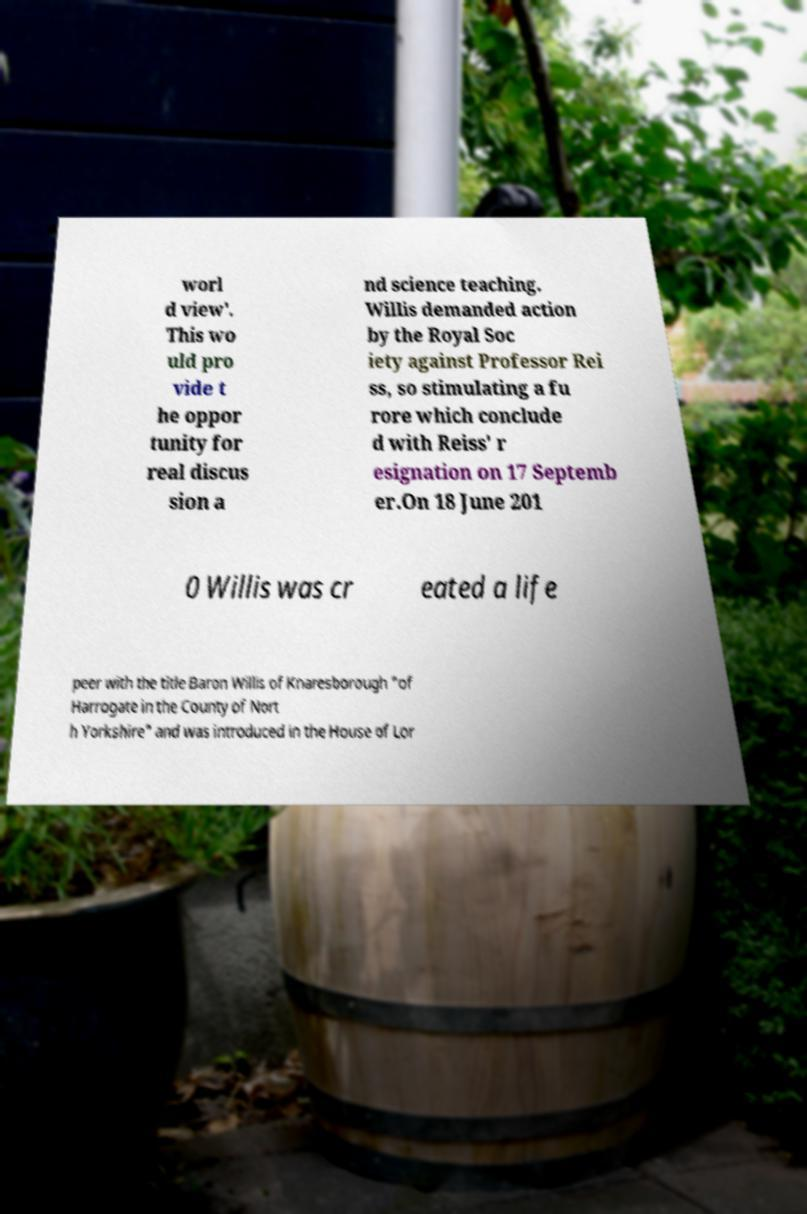I need the written content from this picture converted into text. Can you do that? worl d view'. This wo uld pro vide t he oppor tunity for real discus sion a nd science teaching. Willis demanded action by the Royal Soc iety against Professor Rei ss, so stimulating a fu rore which conclude d with Reiss' r esignation on 17 Septemb er.On 18 June 201 0 Willis was cr eated a life peer with the title Baron Willis of Knaresborough "of Harrogate in the County of Nort h Yorkshire" and was introduced in the House of Lor 